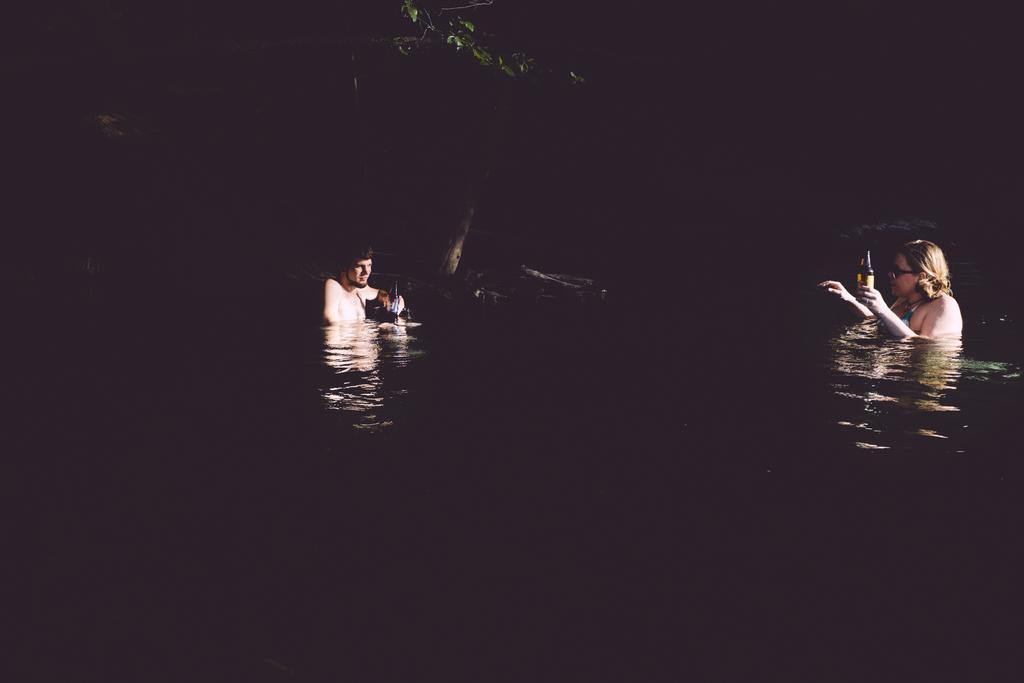How many people are in the water in the image? There are two people in the water in the image. What can be seen in the background of the image? There is a tree visible in the background of the image. What type of pen is being used by one of the people in the water? There is no pen present in the image; both people are in the water. 